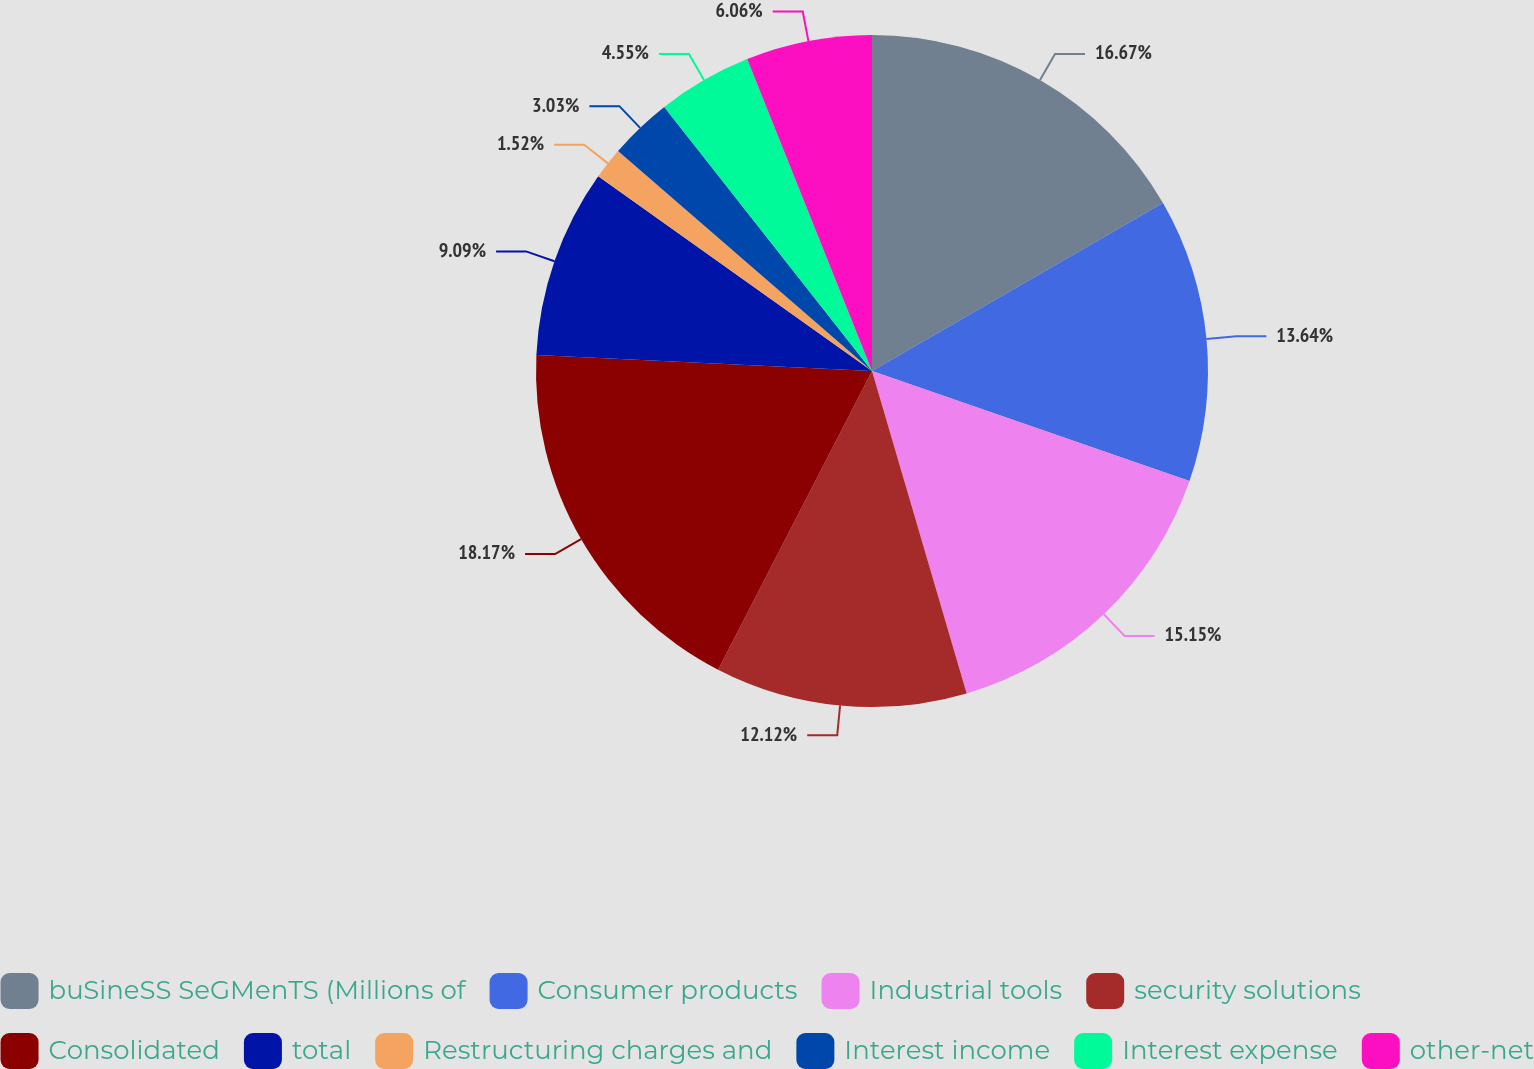<chart> <loc_0><loc_0><loc_500><loc_500><pie_chart><fcel>buSineSS SeGMenTS (Millions of<fcel>Consumer products<fcel>Industrial tools<fcel>security solutions<fcel>Consolidated<fcel>total<fcel>Restructuring charges and<fcel>Interest income<fcel>Interest expense<fcel>other-net<nl><fcel>16.67%<fcel>13.64%<fcel>15.15%<fcel>12.12%<fcel>18.18%<fcel>9.09%<fcel>1.52%<fcel>3.03%<fcel>4.55%<fcel>6.06%<nl></chart> 